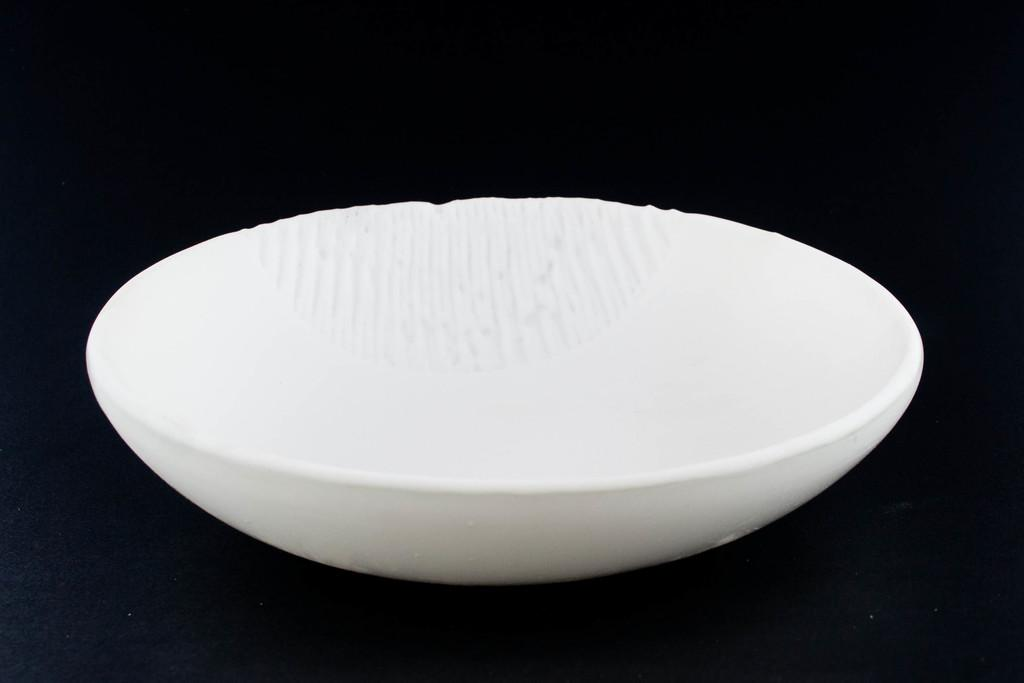What is the main subject in the center of the image? There is a bowl in the center of the image. What color is the bowl? The bowl is white in color. What can be observed about the background of the image? The background of the image is dark. Where is the playground located in the image? There is no playground present in the image. What type of wine is being served in the image? There is no wine present in the image. 